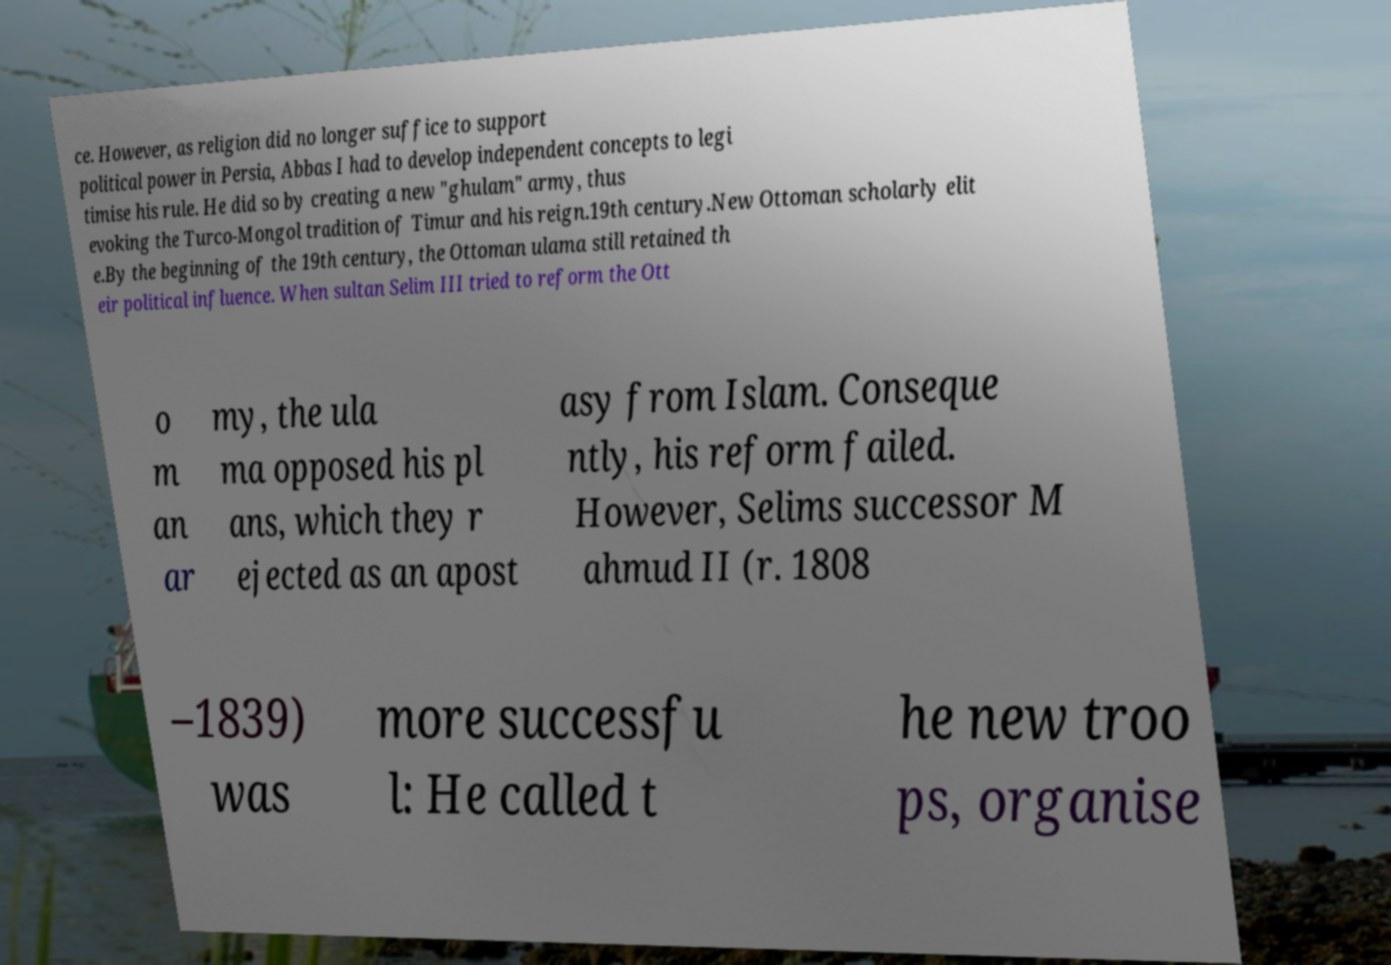I need the written content from this picture converted into text. Can you do that? ce. However, as religion did no longer suffice to support political power in Persia, Abbas I had to develop independent concepts to legi timise his rule. He did so by creating a new "ghulam" army, thus evoking the Turco-Mongol tradition of Timur and his reign.19th century.New Ottoman scholarly elit e.By the beginning of the 19th century, the Ottoman ulama still retained th eir political influence. When sultan Selim III tried to reform the Ott o m an ar my, the ula ma opposed his pl ans, which they r ejected as an apost asy from Islam. Conseque ntly, his reform failed. However, Selims successor M ahmud II (r. 1808 –1839) was more successfu l: He called t he new troo ps, organise 